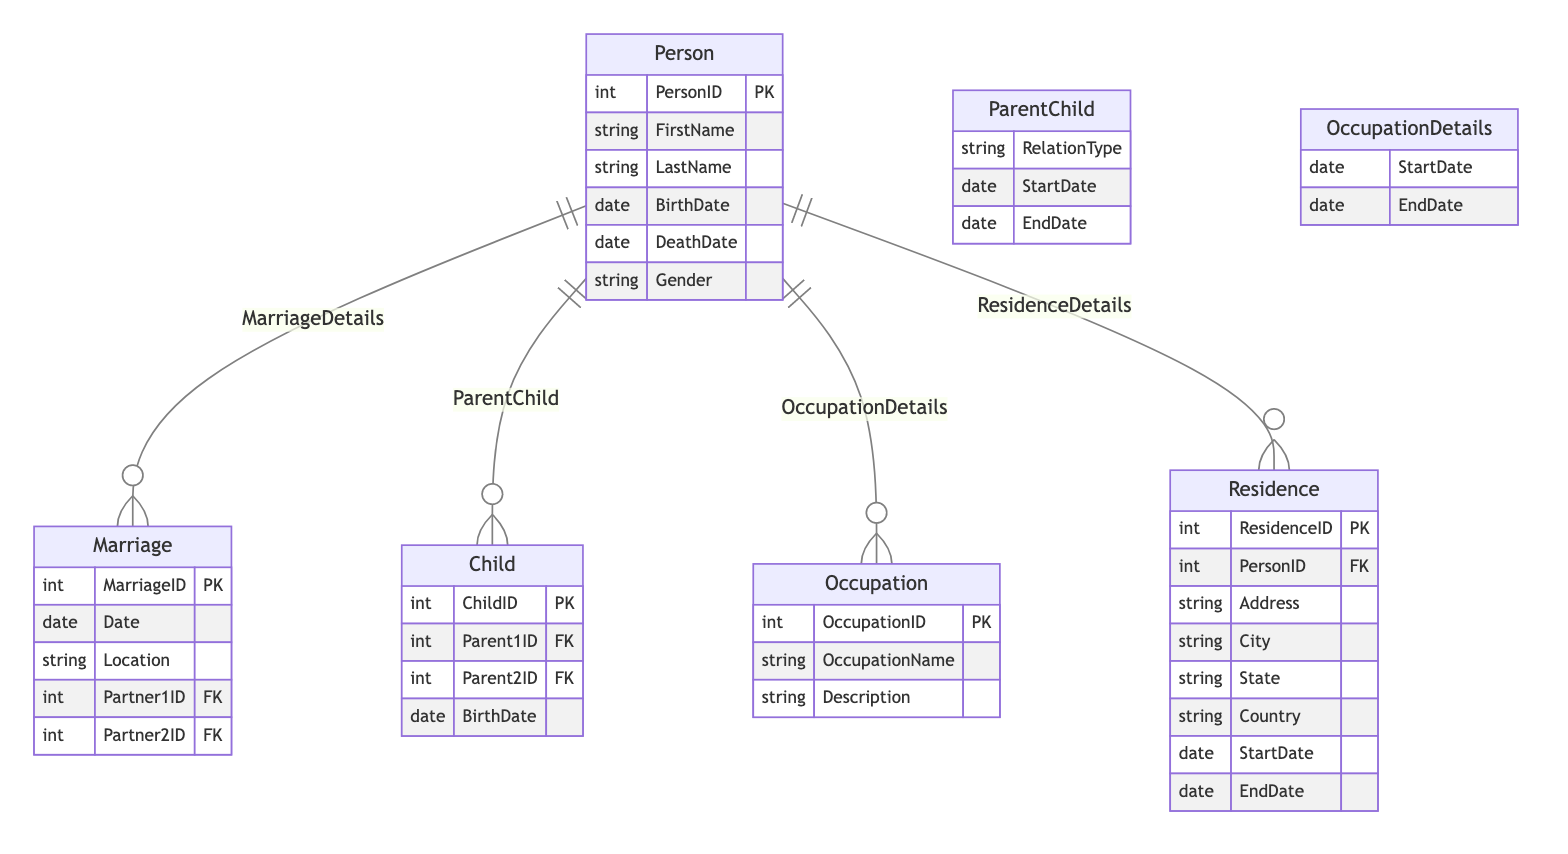What is the primary ID used to identify a person? The diagram indicates that the Person entity has an attribute called PersonID, which acts as the primary identifier for each person.
Answer: PersonID Which entity contains details about marriages? The diagram shows that the Marriage entity holds information related to marriages, including attributes such as MarriageID, Date, and Location.
Answer: Marriage How many relationships are defined in this diagram? The diagram lists four specific relationships: ParentChild, MarriageDetails, OccupationDetails, and ResidenceDetails, totaling to four relationships.
Answer: 4 What type of relationship connects Person and Child? The diagram illustrates that the relationship between Person and Child is defined as ParentChild, which signifies parental relationships between individuals.
Answer: ParentChild What attributes are associated with the Occupation entity? The diagram specifies that the Occupation entity has three attributes: OccupationID, OccupationName, and Description.
Answer: OccupationID, OccupationName, Description What is the relation type included in the ParentChild entity? The ParentChild relationship includes an attribute named RelationType, which describes the nature of the relationship between the two persons involved.
Answer: RelationType How many attributes does the Marriage entity have? According to the diagram, the Marriage entity possesses four attributes: MarriageID, Date, Location, Partner1ID, and Partner2ID, leading to a total of four.
Answer: 4 What additional information is specified in the OccupationDetails relationship? The OccupationDetails relationship has two specific attributes: StartDate and EndDate, which denote the duration of each person's occupation.
Answer: StartDate, EndDate Which entity would you look at to find where a person has lived? The Residence entity contains various attributes describing where a person has lived, such as Address, City, State, and Country.
Answer: Residence 